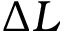Convert formula to latex. <formula><loc_0><loc_0><loc_500><loc_500>\Delta L</formula> 